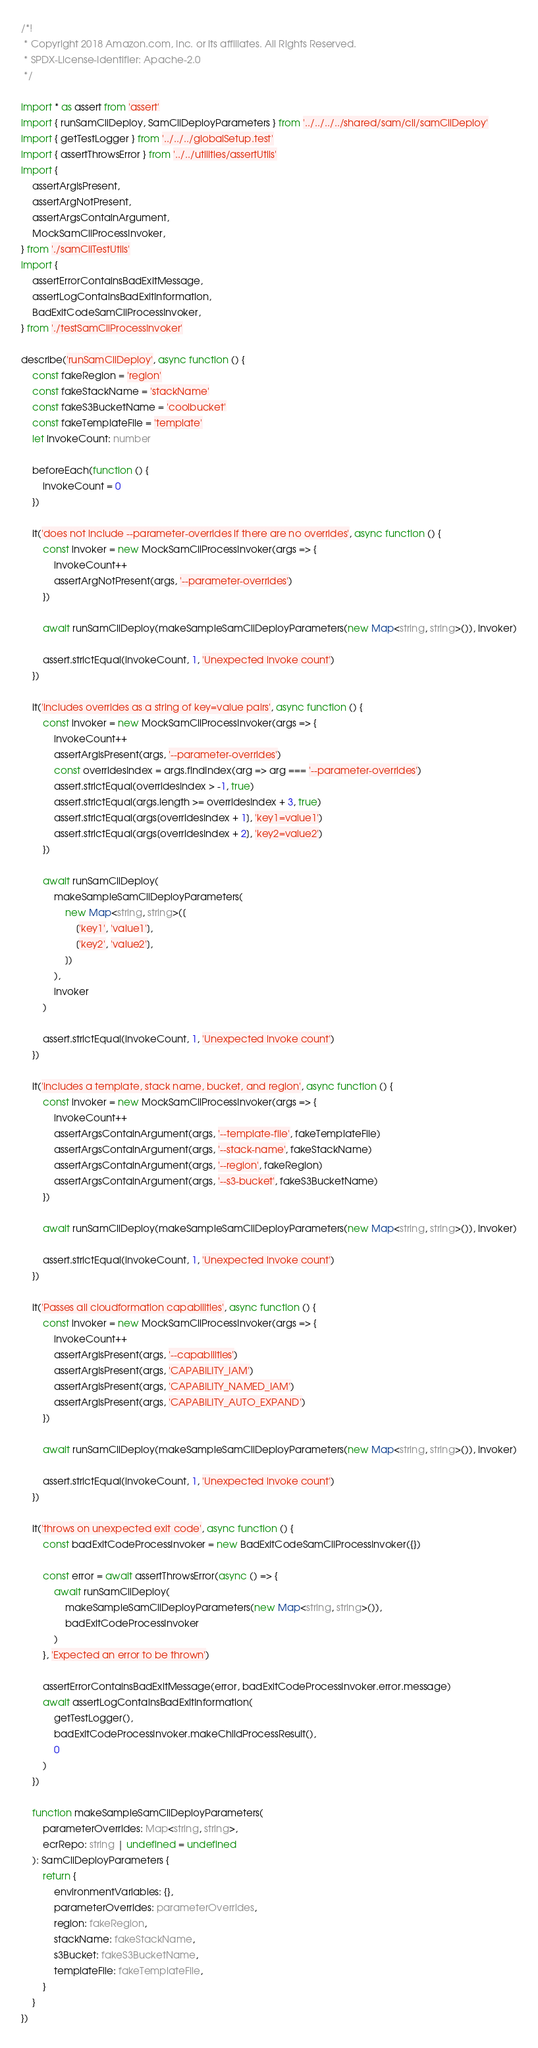Convert code to text. <code><loc_0><loc_0><loc_500><loc_500><_TypeScript_>/*!
 * Copyright 2018 Amazon.com, Inc. or its affiliates. All Rights Reserved.
 * SPDX-License-Identifier: Apache-2.0
 */

import * as assert from 'assert'
import { runSamCliDeploy, SamCliDeployParameters } from '../../../../shared/sam/cli/samCliDeploy'
import { getTestLogger } from '../../../globalSetup.test'
import { assertThrowsError } from '../../utilities/assertUtils'
import {
    assertArgIsPresent,
    assertArgNotPresent,
    assertArgsContainArgument,
    MockSamCliProcessInvoker,
} from './samCliTestUtils'
import {
    assertErrorContainsBadExitMessage,
    assertLogContainsBadExitInformation,
    BadExitCodeSamCliProcessInvoker,
} from './testSamCliProcessInvoker'

describe('runSamCliDeploy', async function () {
    const fakeRegion = 'region'
    const fakeStackName = 'stackName'
    const fakeS3BucketName = 'coolbucket'
    const fakeTemplateFile = 'template'
    let invokeCount: number

    beforeEach(function () {
        invokeCount = 0
    })

    it('does not include --parameter-overrides if there are no overrides', async function () {
        const invoker = new MockSamCliProcessInvoker(args => {
            invokeCount++
            assertArgNotPresent(args, '--parameter-overrides')
        })

        await runSamCliDeploy(makeSampleSamCliDeployParameters(new Map<string, string>()), invoker)

        assert.strictEqual(invokeCount, 1, 'Unexpected invoke count')
    })

    it('includes overrides as a string of key=value pairs', async function () {
        const invoker = new MockSamCliProcessInvoker(args => {
            invokeCount++
            assertArgIsPresent(args, '--parameter-overrides')
            const overridesIndex = args.findIndex(arg => arg === '--parameter-overrides')
            assert.strictEqual(overridesIndex > -1, true)
            assert.strictEqual(args.length >= overridesIndex + 3, true)
            assert.strictEqual(args[overridesIndex + 1], 'key1=value1')
            assert.strictEqual(args[overridesIndex + 2], 'key2=value2')
        })

        await runSamCliDeploy(
            makeSampleSamCliDeployParameters(
                new Map<string, string>([
                    ['key1', 'value1'],
                    ['key2', 'value2'],
                ])
            ),
            invoker
        )

        assert.strictEqual(invokeCount, 1, 'Unexpected invoke count')
    })

    it('includes a template, stack name, bucket, and region', async function () {
        const invoker = new MockSamCliProcessInvoker(args => {
            invokeCount++
            assertArgsContainArgument(args, '--template-file', fakeTemplateFile)
            assertArgsContainArgument(args, '--stack-name', fakeStackName)
            assertArgsContainArgument(args, '--region', fakeRegion)
            assertArgsContainArgument(args, '--s3-bucket', fakeS3BucketName)
        })

        await runSamCliDeploy(makeSampleSamCliDeployParameters(new Map<string, string>()), invoker)

        assert.strictEqual(invokeCount, 1, 'Unexpected invoke count')
    })

    it('Passes all cloudformation capabilities', async function () {
        const invoker = new MockSamCliProcessInvoker(args => {
            invokeCount++
            assertArgIsPresent(args, '--capabilities')
            assertArgIsPresent(args, 'CAPABILITY_IAM')
            assertArgIsPresent(args, 'CAPABILITY_NAMED_IAM')
            assertArgIsPresent(args, 'CAPABILITY_AUTO_EXPAND')
        })

        await runSamCliDeploy(makeSampleSamCliDeployParameters(new Map<string, string>()), invoker)

        assert.strictEqual(invokeCount, 1, 'Unexpected invoke count')
    })

    it('throws on unexpected exit code', async function () {
        const badExitCodeProcessInvoker = new BadExitCodeSamCliProcessInvoker({})

        const error = await assertThrowsError(async () => {
            await runSamCliDeploy(
                makeSampleSamCliDeployParameters(new Map<string, string>()),
                badExitCodeProcessInvoker
            )
        }, 'Expected an error to be thrown')

        assertErrorContainsBadExitMessage(error, badExitCodeProcessInvoker.error.message)
        await assertLogContainsBadExitInformation(
            getTestLogger(),
            badExitCodeProcessInvoker.makeChildProcessResult(),
            0
        )
    })

    function makeSampleSamCliDeployParameters(
        parameterOverrides: Map<string, string>,
        ecrRepo: string | undefined = undefined
    ): SamCliDeployParameters {
        return {
            environmentVariables: {},
            parameterOverrides: parameterOverrides,
            region: fakeRegion,
            stackName: fakeStackName,
            s3Bucket: fakeS3BucketName,
            templateFile: fakeTemplateFile,
        }
    }
})
</code> 